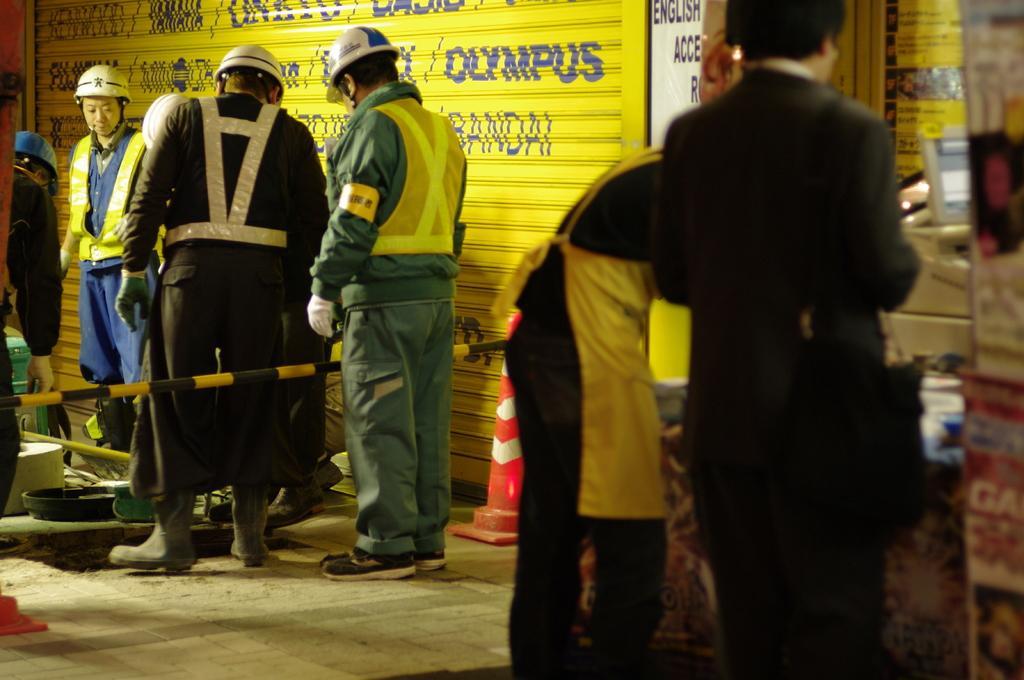Please provide a concise description of this image. In this picture I can see few people standing and few of them wore caps on their heads and I can see couple of cones and a metal rod and I can see e store on the side and I can see a text. 